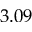Convert formula to latex. <formula><loc_0><loc_0><loc_500><loc_500>3 . 0 9</formula> 